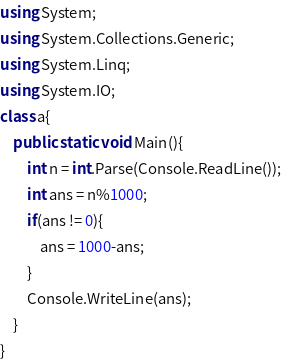Convert code to text. <code><loc_0><loc_0><loc_500><loc_500><_C#_>using System;
using System.Collections.Generic;
using System.Linq;
using System.IO;
class a{
    public static void Main(){
        int n = int.Parse(Console.ReadLine());
        int ans = n%1000;
        if(ans != 0){
            ans = 1000-ans;
        }
        Console.WriteLine(ans);
    }
}
</code> 